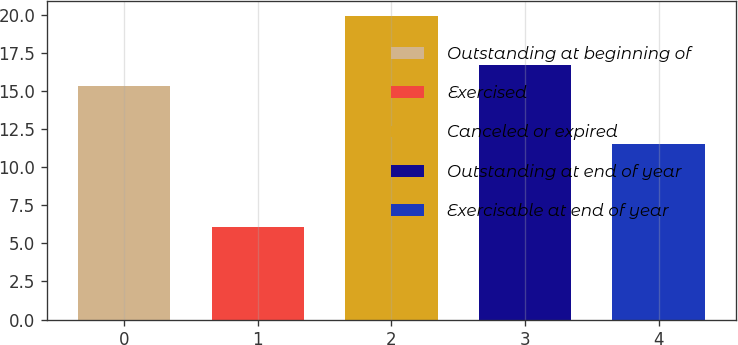Convert chart to OTSL. <chart><loc_0><loc_0><loc_500><loc_500><bar_chart><fcel>Outstanding at beginning of<fcel>Exercised<fcel>Canceled or expired<fcel>Outstanding at end of year<fcel>Exercisable at end of year<nl><fcel>15.31<fcel>6.06<fcel>19.93<fcel>16.7<fcel>11.54<nl></chart> 